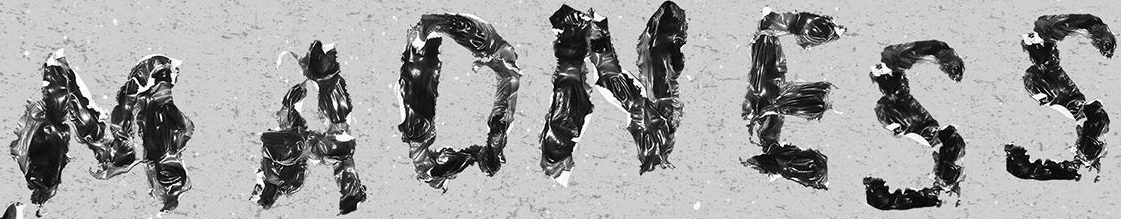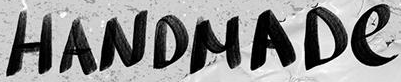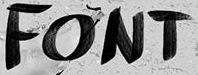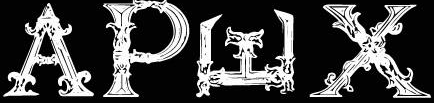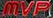What text is displayed in these images sequentially, separated by a semicolon? MADNESS; HANDMADe; FONT; APWX; MVP 